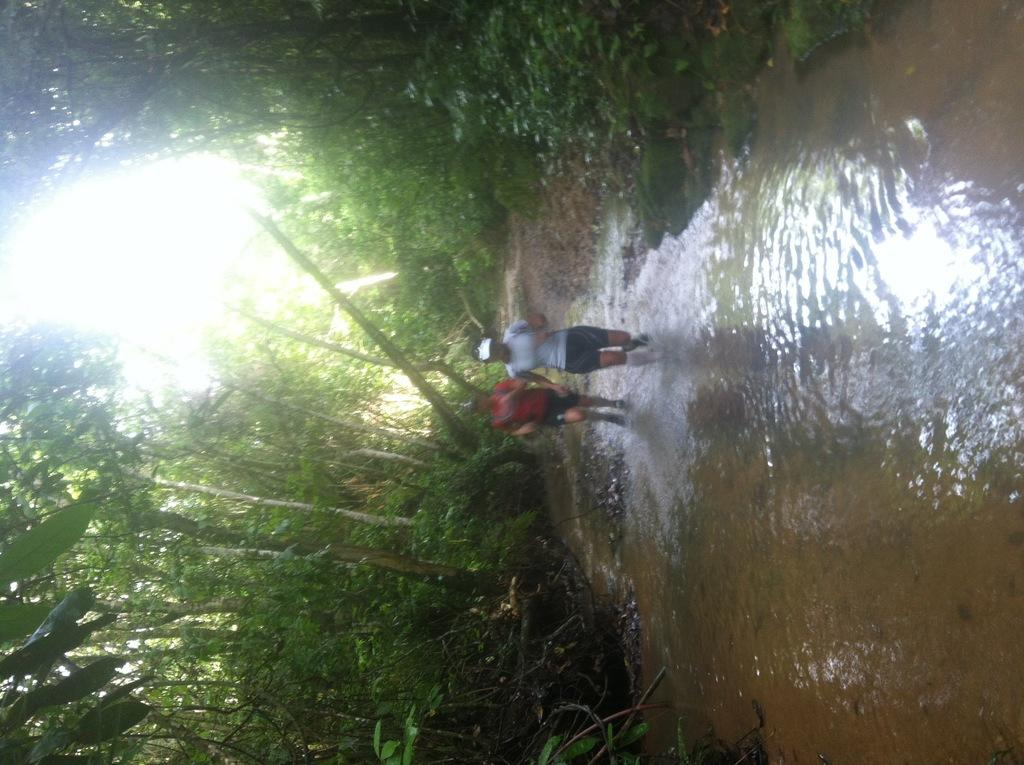How many people are present in the image? There are two people in the image. What is visible in the image besides the people? Water and trees are visible in the image. What type of bean is being used in the operation depicted in the image? There is no operation or bean present in the image. 